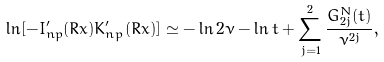Convert formula to latex. <formula><loc_0><loc_0><loc_500><loc_500>\ln [ - I _ { n p } ^ { \prime } ( R x ) K _ { n p } ^ { \prime } ( R x ) ] \simeq - \ln 2 \nu - \ln t + \sum _ { j = 1 } ^ { 2 } \frac { G _ { 2 j } ^ { N } ( t ) } { \nu ^ { 2 j } } ,</formula> 